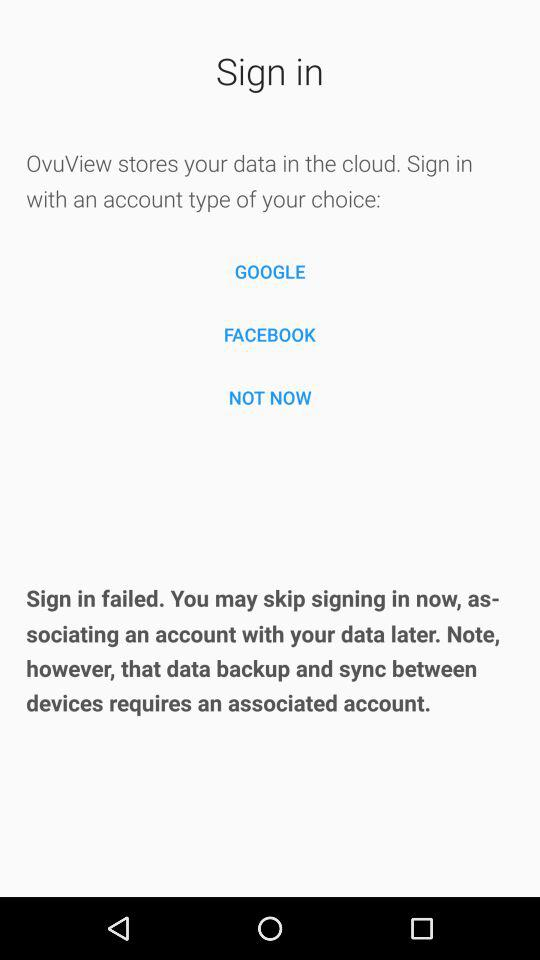From which app can we sign in? You can sign in with "GOOGLE" and "FACEBOOK". 